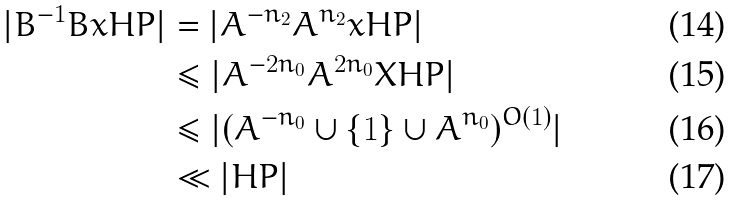<formula> <loc_0><loc_0><loc_500><loc_500>| B ^ { - 1 } B x H P | & = | A ^ { - n _ { 2 } } A ^ { n _ { 2 } } x H P | \\ & \leq | A ^ { - 2 n _ { 0 } } A ^ { 2 n _ { 0 } } X H P | \\ & \leq | ( A ^ { - n _ { 0 } } \cup \{ 1 \} \cup A ^ { n _ { 0 } } ) ^ { O ( 1 ) } | \\ & \ll | H P |</formula> 